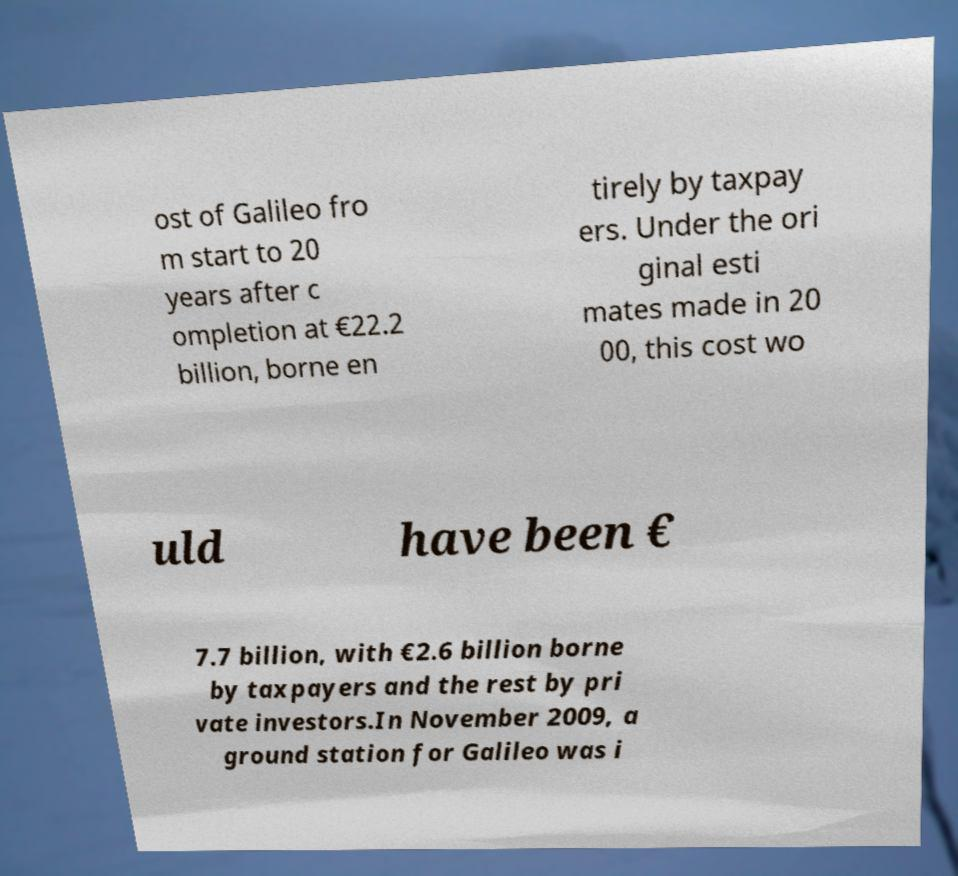Please identify and transcribe the text found in this image. ost of Galileo fro m start to 20 years after c ompletion at €22.2 billion, borne en tirely by taxpay ers. Under the ori ginal esti mates made in 20 00, this cost wo uld have been € 7.7 billion, with €2.6 billion borne by taxpayers and the rest by pri vate investors.In November 2009, a ground station for Galileo was i 